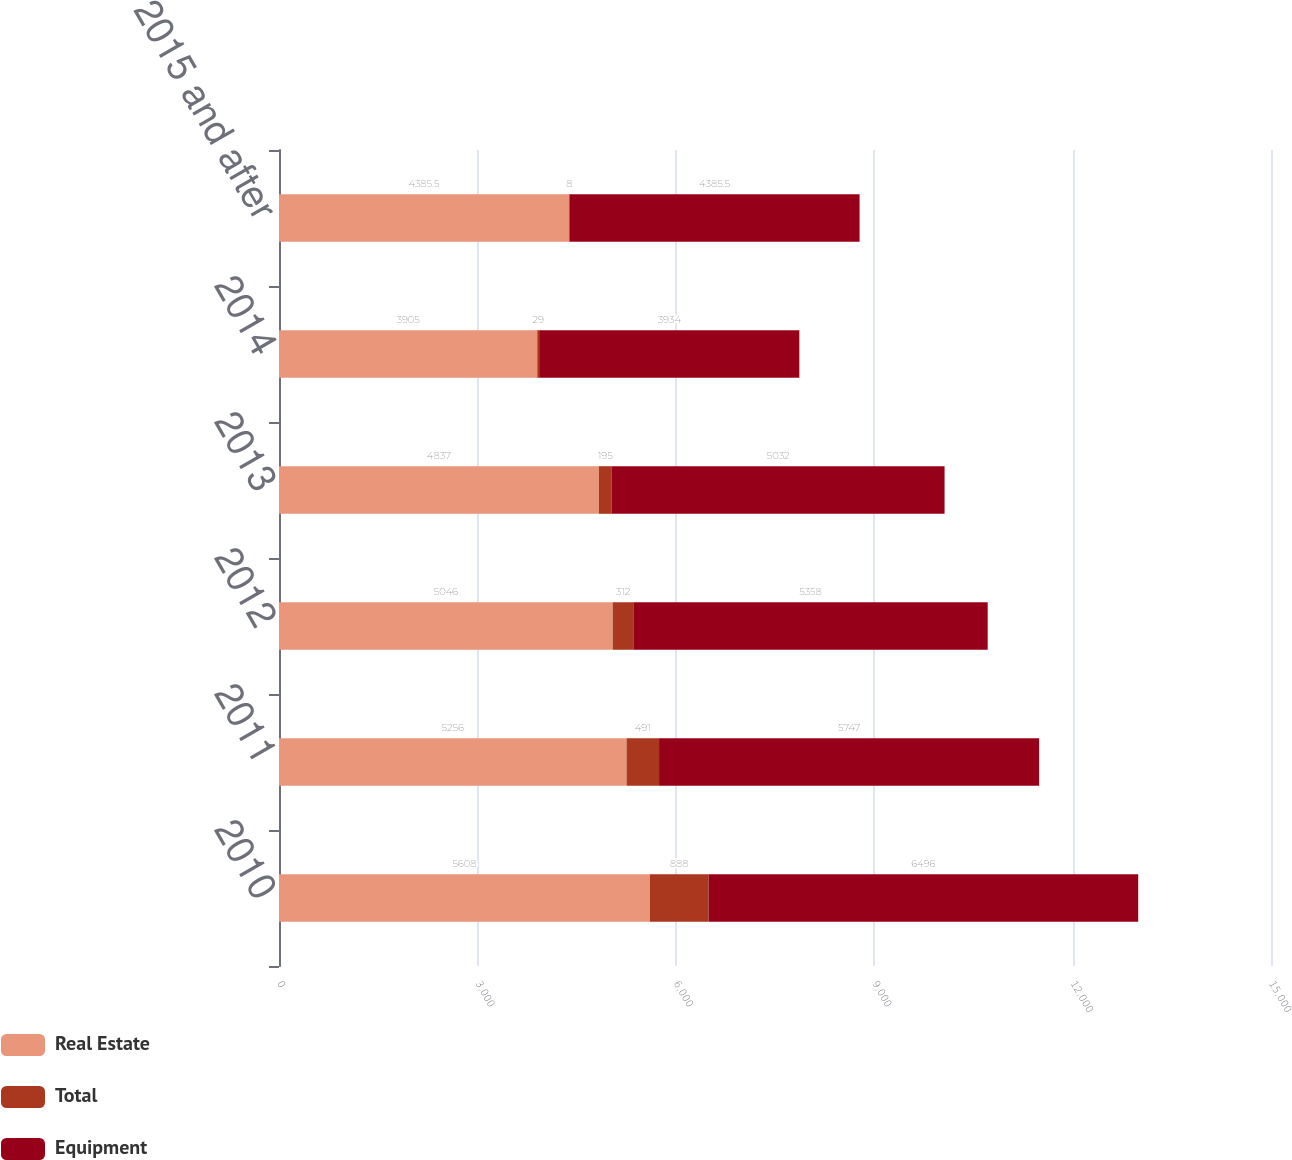<chart> <loc_0><loc_0><loc_500><loc_500><stacked_bar_chart><ecel><fcel>2010<fcel>2011<fcel>2012<fcel>2013<fcel>2014<fcel>2015 and after<nl><fcel>Real Estate<fcel>5608<fcel>5256<fcel>5046<fcel>4837<fcel>3905<fcel>4385.5<nl><fcel>Total<fcel>888<fcel>491<fcel>312<fcel>195<fcel>29<fcel>8<nl><fcel>Equipment<fcel>6496<fcel>5747<fcel>5358<fcel>5032<fcel>3934<fcel>4385.5<nl></chart> 